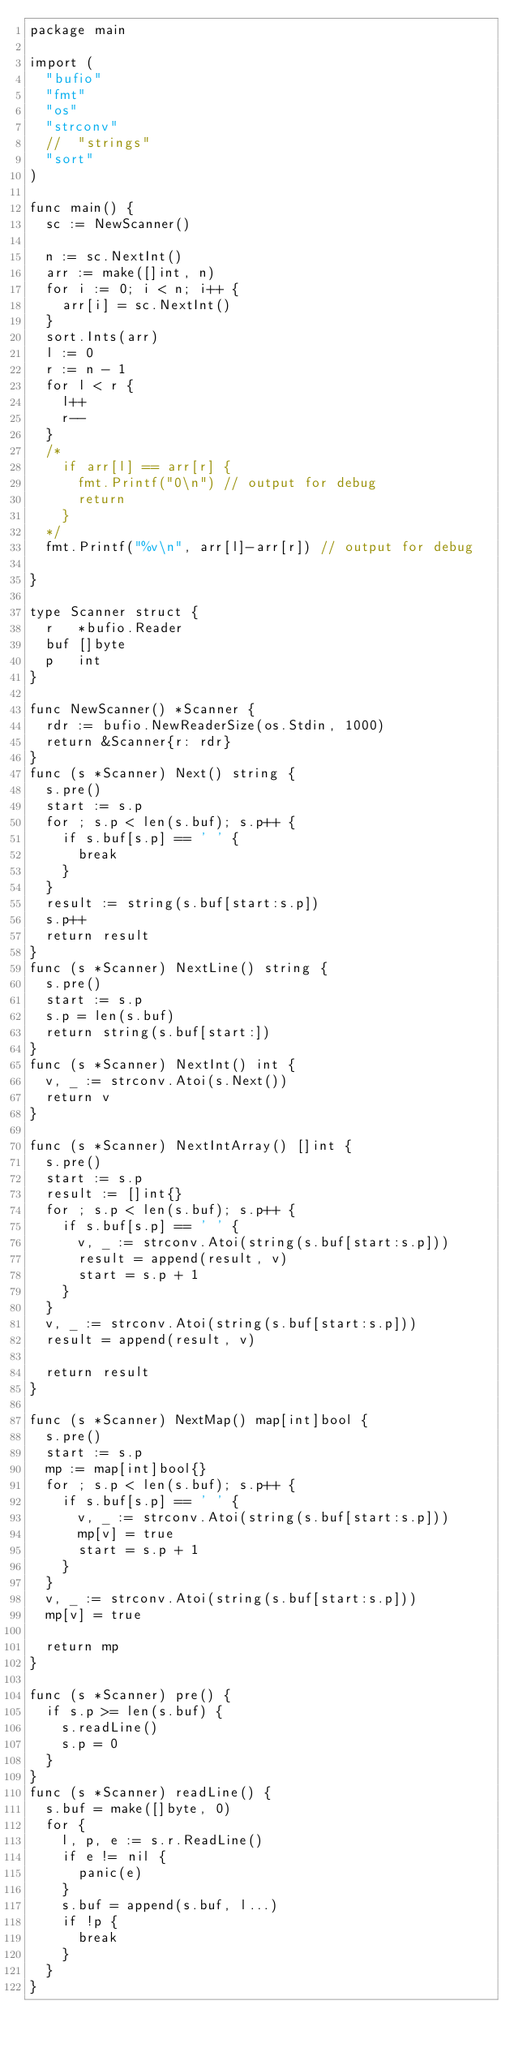Convert code to text. <code><loc_0><loc_0><loc_500><loc_500><_Go_>package main

import (
	"bufio"
	"fmt"
	"os"
	"strconv"
	//	"strings"
	"sort"
)

func main() {
	sc := NewScanner()

	n := sc.NextInt()
	arr := make([]int, n)
	for i := 0; i < n; i++ {
		arr[i] = sc.NextInt()
	}
	sort.Ints(arr)
	l := 0
	r := n - 1
	for l < r {
		l++
		r--
	}
	/*
		if arr[l] == arr[r] {
			fmt.Printf("0\n") // output for debug
			return
		}
	*/
	fmt.Printf("%v\n", arr[l]-arr[r]) // output for debug

}

type Scanner struct {
	r   *bufio.Reader
	buf []byte
	p   int
}

func NewScanner() *Scanner {
	rdr := bufio.NewReaderSize(os.Stdin, 1000)
	return &Scanner{r: rdr}
}
func (s *Scanner) Next() string {
	s.pre()
	start := s.p
	for ; s.p < len(s.buf); s.p++ {
		if s.buf[s.p] == ' ' {
			break
		}
	}
	result := string(s.buf[start:s.p])
	s.p++
	return result
}
func (s *Scanner) NextLine() string {
	s.pre()
	start := s.p
	s.p = len(s.buf)
	return string(s.buf[start:])
}
func (s *Scanner) NextInt() int {
	v, _ := strconv.Atoi(s.Next())
	return v
}

func (s *Scanner) NextIntArray() []int {
	s.pre()
	start := s.p
	result := []int{}
	for ; s.p < len(s.buf); s.p++ {
		if s.buf[s.p] == ' ' {
			v, _ := strconv.Atoi(string(s.buf[start:s.p]))
			result = append(result, v)
			start = s.p + 1
		}
	}
	v, _ := strconv.Atoi(string(s.buf[start:s.p]))
	result = append(result, v)

	return result
}

func (s *Scanner) NextMap() map[int]bool {
	s.pre()
	start := s.p
	mp := map[int]bool{}
	for ; s.p < len(s.buf); s.p++ {
		if s.buf[s.p] == ' ' {
			v, _ := strconv.Atoi(string(s.buf[start:s.p]))
			mp[v] = true
			start = s.p + 1
		}
	}
	v, _ := strconv.Atoi(string(s.buf[start:s.p]))
	mp[v] = true

	return mp
}

func (s *Scanner) pre() {
	if s.p >= len(s.buf) {
		s.readLine()
		s.p = 0
	}
}
func (s *Scanner) readLine() {
	s.buf = make([]byte, 0)
	for {
		l, p, e := s.r.ReadLine()
		if e != nil {
			panic(e)
		}
		s.buf = append(s.buf, l...)
		if !p {
			break
		}
	}
}
</code> 